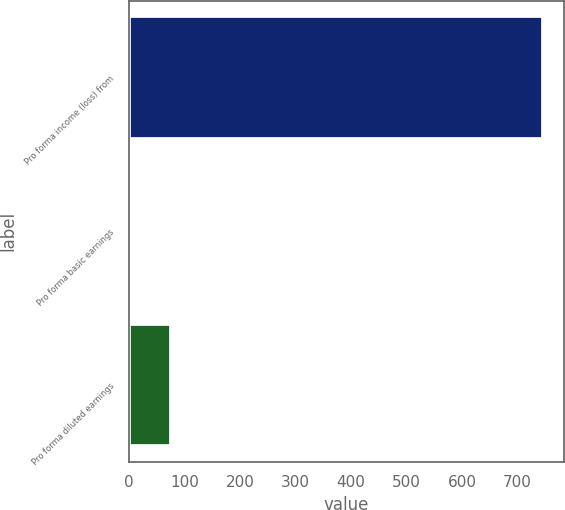Convert chart to OTSL. <chart><loc_0><loc_0><loc_500><loc_500><bar_chart><fcel>Pro forma income (loss) from<fcel>Pro forma basic earnings<fcel>Pro forma diluted earnings<nl><fcel>746.9<fcel>1.26<fcel>75.82<nl></chart> 